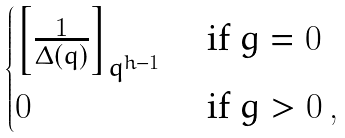<formula> <loc_0><loc_0><loc_500><loc_500>\begin{cases} \left [ \frac { 1 } { \Delta ( q ) } \right ] _ { q ^ { h - 1 } } & \text { if } g = 0 \\ 0 & \text { if } g > 0 \, , \end{cases}</formula> 